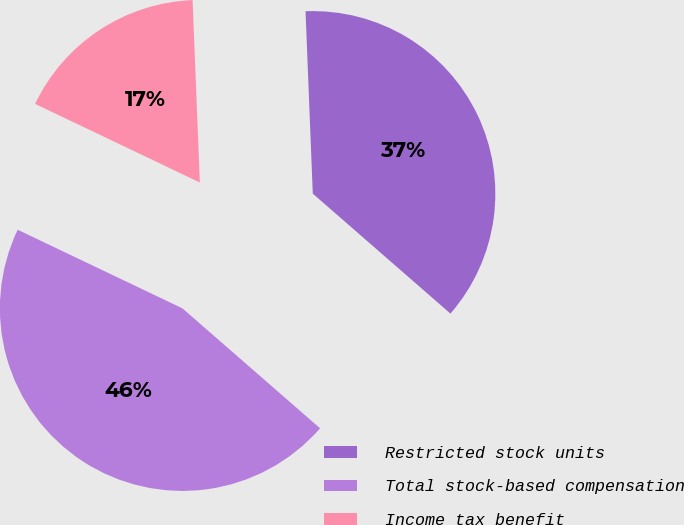Convert chart to OTSL. <chart><loc_0><loc_0><loc_500><loc_500><pie_chart><fcel>Restricted stock units<fcel>Total stock-based compensation<fcel>Income tax benefit<nl><fcel>37.04%<fcel>45.68%<fcel>17.28%<nl></chart> 